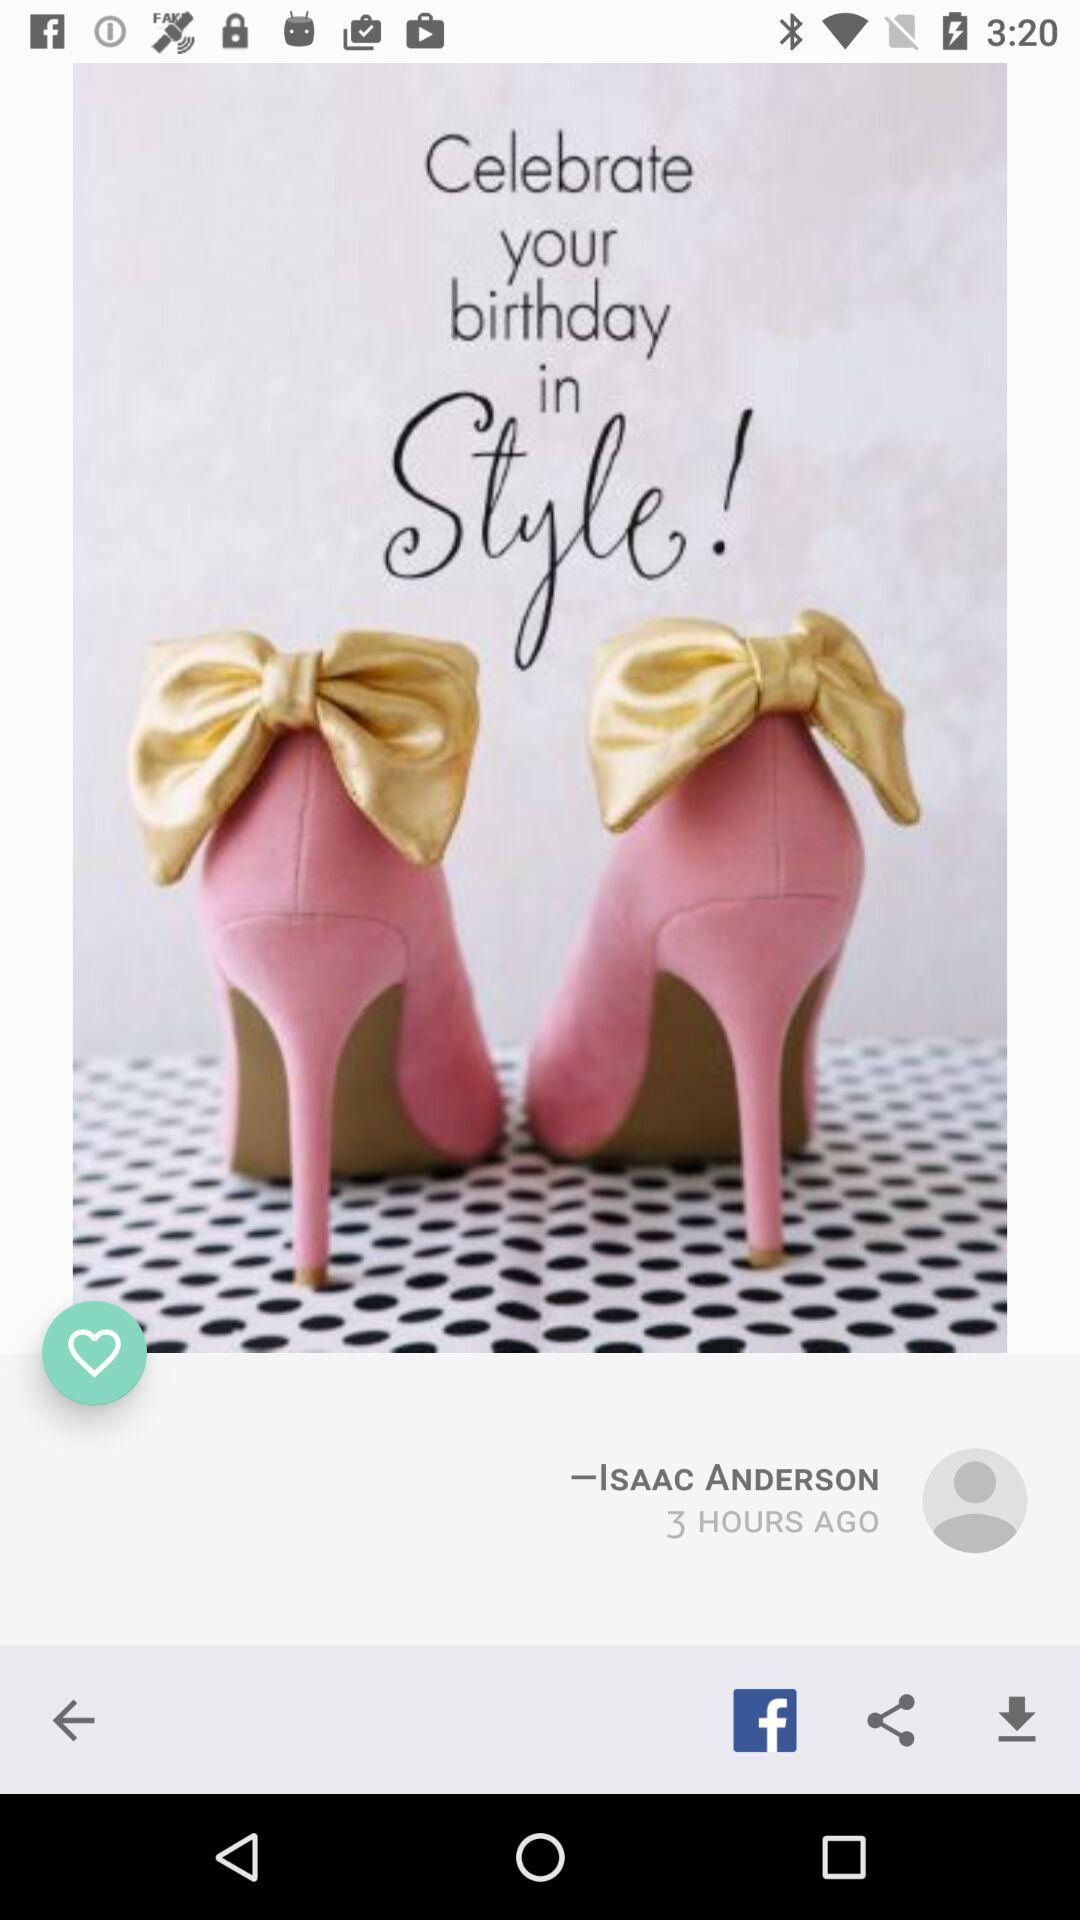When did the user post the post? The user posted the post 3 hours ago. 